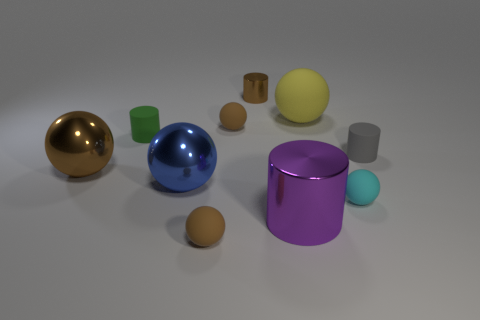What shape is the big thing that is the same color as the tiny shiny object?
Provide a succinct answer. Sphere. There is a brown cylinder; is its size the same as the yellow ball behind the large purple object?
Provide a succinct answer. No. There is a tiny brown ball that is behind the gray matte cylinder; what number of tiny gray objects are behind it?
Provide a short and direct response. 0. How many balls are either tiny purple metallic objects or small brown matte objects?
Provide a succinct answer. 2. Is there a small gray sphere?
Ensure brevity in your answer.  No. The cyan thing that is the same shape as the yellow matte object is what size?
Your answer should be compact. Small. There is a brown shiny thing that is in front of the brown metallic thing that is right of the large brown ball; what shape is it?
Offer a very short reply. Sphere. How many cyan things are either big matte spheres or small rubber cubes?
Provide a succinct answer. 0. The big rubber thing has what color?
Keep it short and to the point. Yellow. Does the cyan ball have the same size as the green rubber cylinder?
Your response must be concise. Yes. 